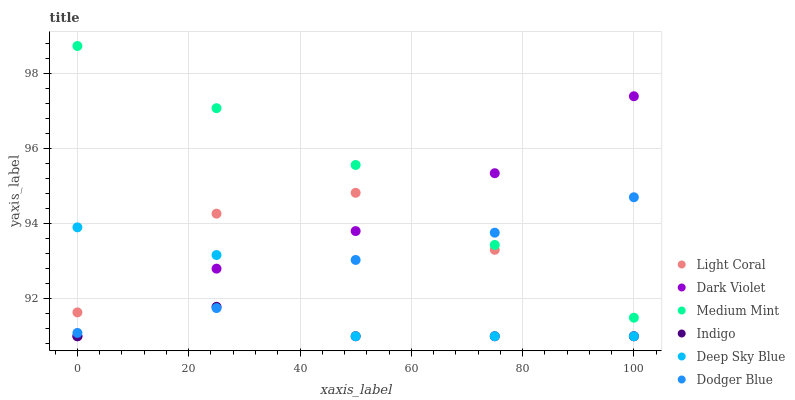Does Indigo have the minimum area under the curve?
Answer yes or no. Yes. Does Medium Mint have the maximum area under the curve?
Answer yes or no. Yes. Does Dark Violet have the minimum area under the curve?
Answer yes or no. No. Does Dark Violet have the maximum area under the curve?
Answer yes or no. No. Is Medium Mint the smoothest?
Answer yes or no. Yes. Is Light Coral the roughest?
Answer yes or no. Yes. Is Indigo the smoothest?
Answer yes or no. No. Is Indigo the roughest?
Answer yes or no. No. Does Indigo have the lowest value?
Answer yes or no. Yes. Does Dodger Blue have the lowest value?
Answer yes or no. No. Does Medium Mint have the highest value?
Answer yes or no. Yes. Does Dark Violet have the highest value?
Answer yes or no. No. Is Indigo less than Medium Mint?
Answer yes or no. Yes. Is Medium Mint greater than Indigo?
Answer yes or no. Yes. Does Deep Sky Blue intersect Dodger Blue?
Answer yes or no. Yes. Is Deep Sky Blue less than Dodger Blue?
Answer yes or no. No. Is Deep Sky Blue greater than Dodger Blue?
Answer yes or no. No. Does Indigo intersect Medium Mint?
Answer yes or no. No. 